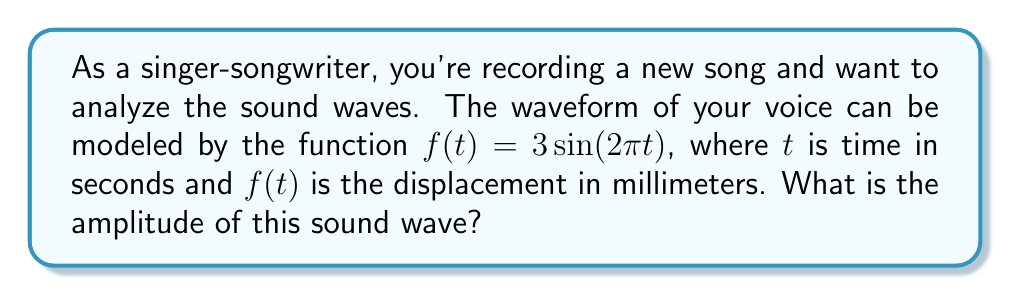Give your solution to this math problem. Let's approach this step-by-step:

1) The general form of a sine wave is:

   $$f(t) = A\sin(Bt + C) + D$$

   where $A$ is the amplitude, $B$ is the angular frequency, $C$ is the phase shift, and $D$ is the vertical shift.

2) In our case, we have:

   $$f(t) = 3\sin(2\pi t)$$

3) Comparing this to the general form, we can see that:
   - $A = 3$
   - $B = 2\pi$
   - $C = 0$ (no phase shift)
   - $D = 0$ (no vertical shift)

4) The amplitude is the value of $A$, which represents the maximum displacement from the equilibrium position.

5) Therefore, the amplitude of this sound wave is 3 millimeters.
Answer: 3 mm 